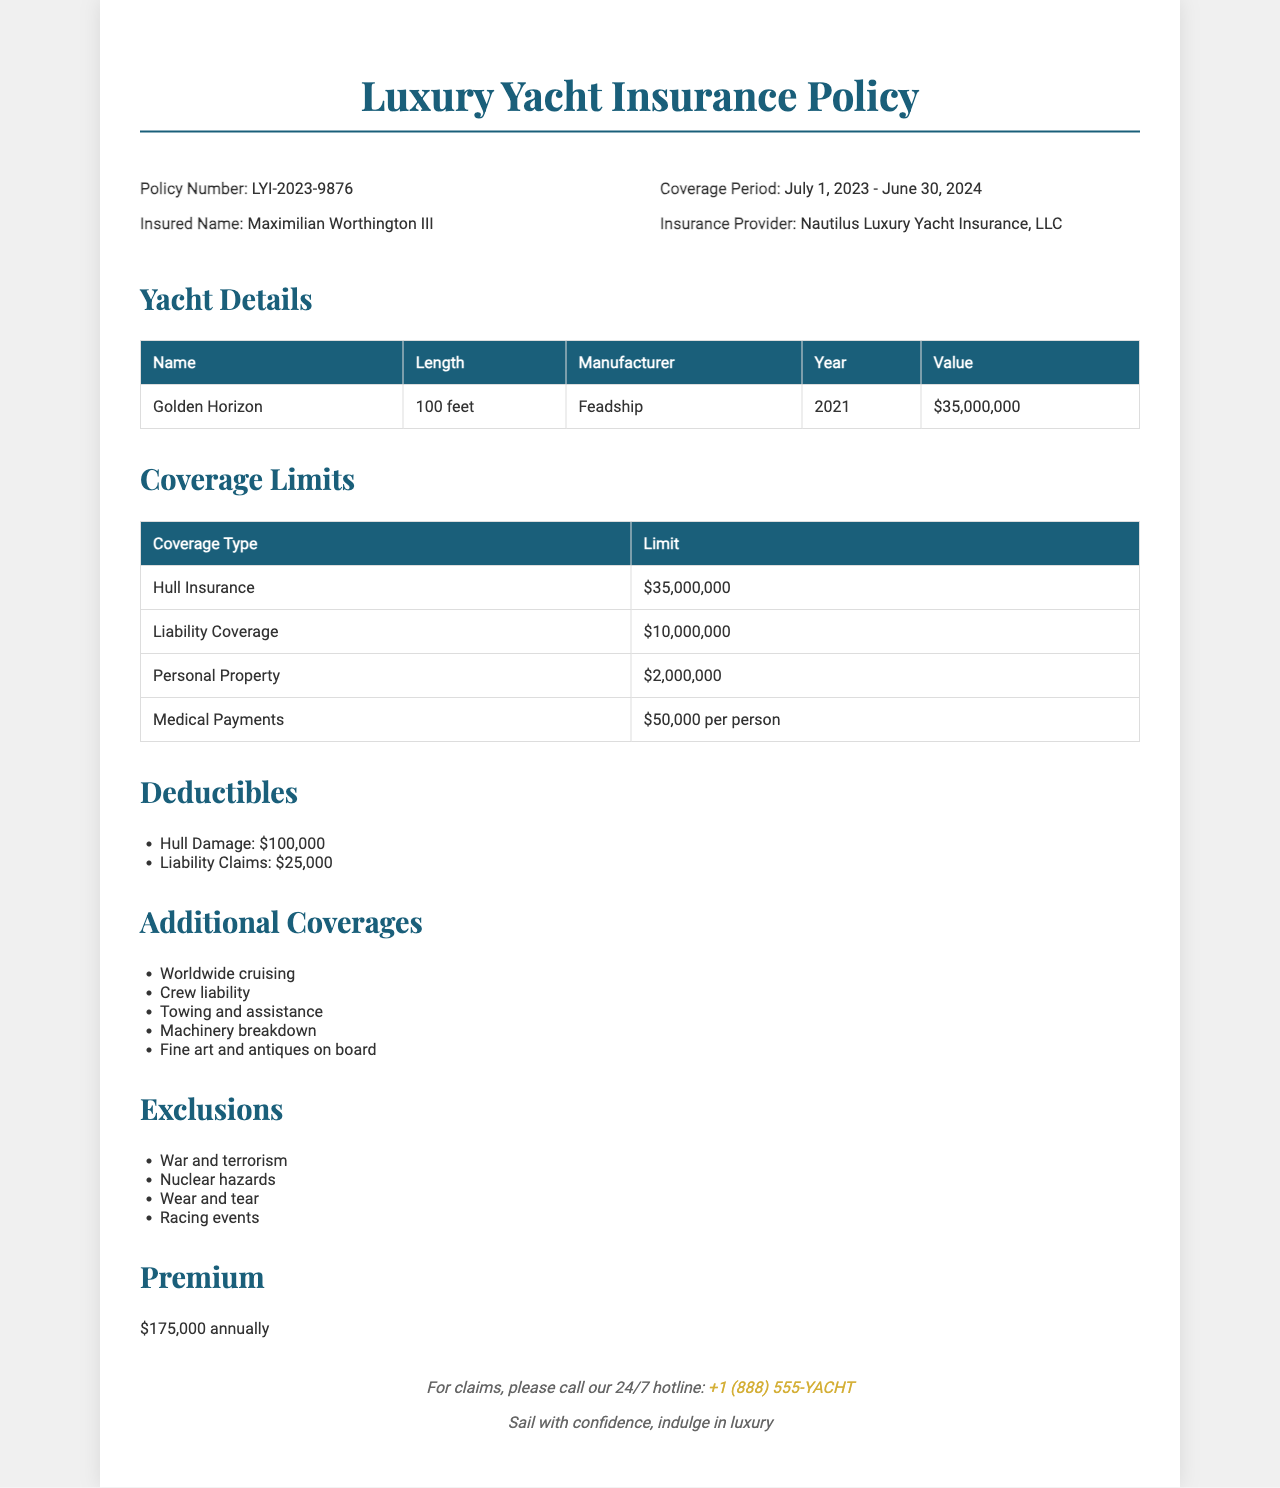What is the policy number? The policy number is mentioned as LYI-2023-9876 in the document.
Answer: LYI-2023-9876 Who is the insured name? The document specifies that the insured name is Maximilian Worthington III.
Answer: Maximilian Worthington III What is the value of the yacht? The yacht's value is listed as $35,000,000 in the yacht details section.
Answer: $35,000,000 What is the liability coverage limit? The limit for liability coverage is stated as $10,000,000 in the coverage limits table.
Answer: $10,000,000 What is the annual premium amount? The document specifies that the annual premium is $175,000.
Answer: $175,000 Which company provides this insurance? The insurance provider is identified as Nautilus Luxury Yacht Insurance, LLC.
Answer: Nautilus Luxury Yacht Insurance, LLC What is the deductible for hull damage? The deductible for hull damage is set at $100,000 according to the deductibles list.
Answer: $100,000 What type of additional coverage involves crew? The document lists crew liability as an additional coverage option.
Answer: Crew liability What is excluded under the policy? The exclusions section mentions that war and terrorism are excluded.
Answer: War and terrorism What is the coverage period of the policy? The coverage period is specified as July 1, 2023 - June 30, 2024.
Answer: July 1, 2023 - June 30, 2024 